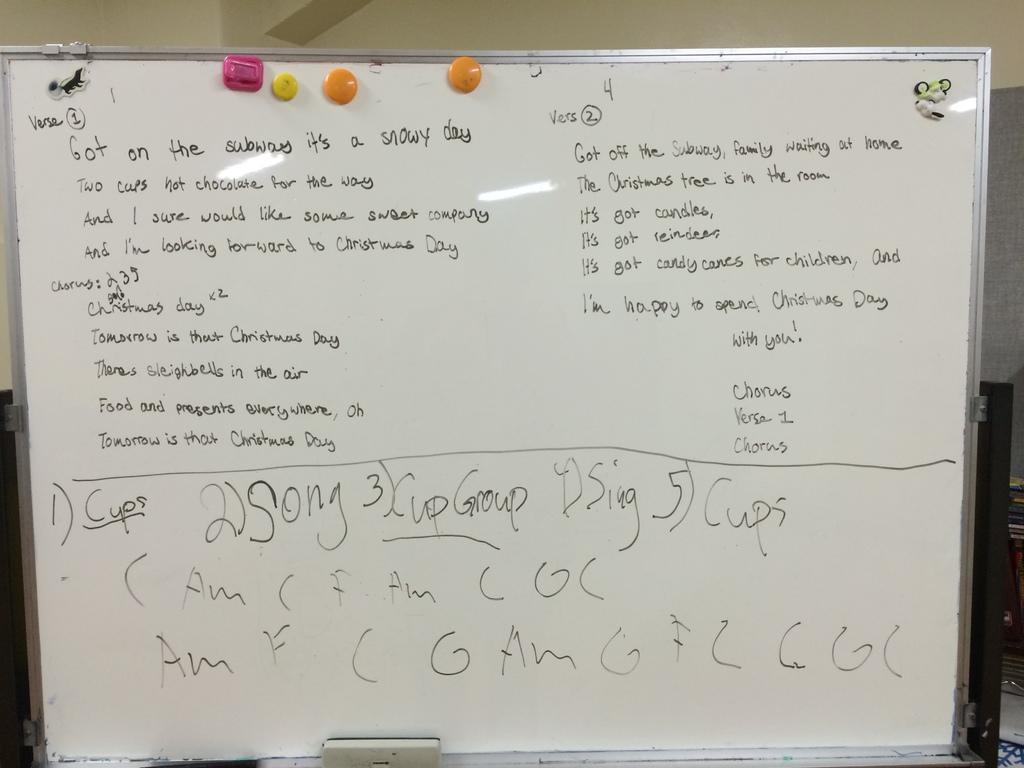<image>
Create a compact narrative representing the image presented. A white board has notes which begin with verse 1. 